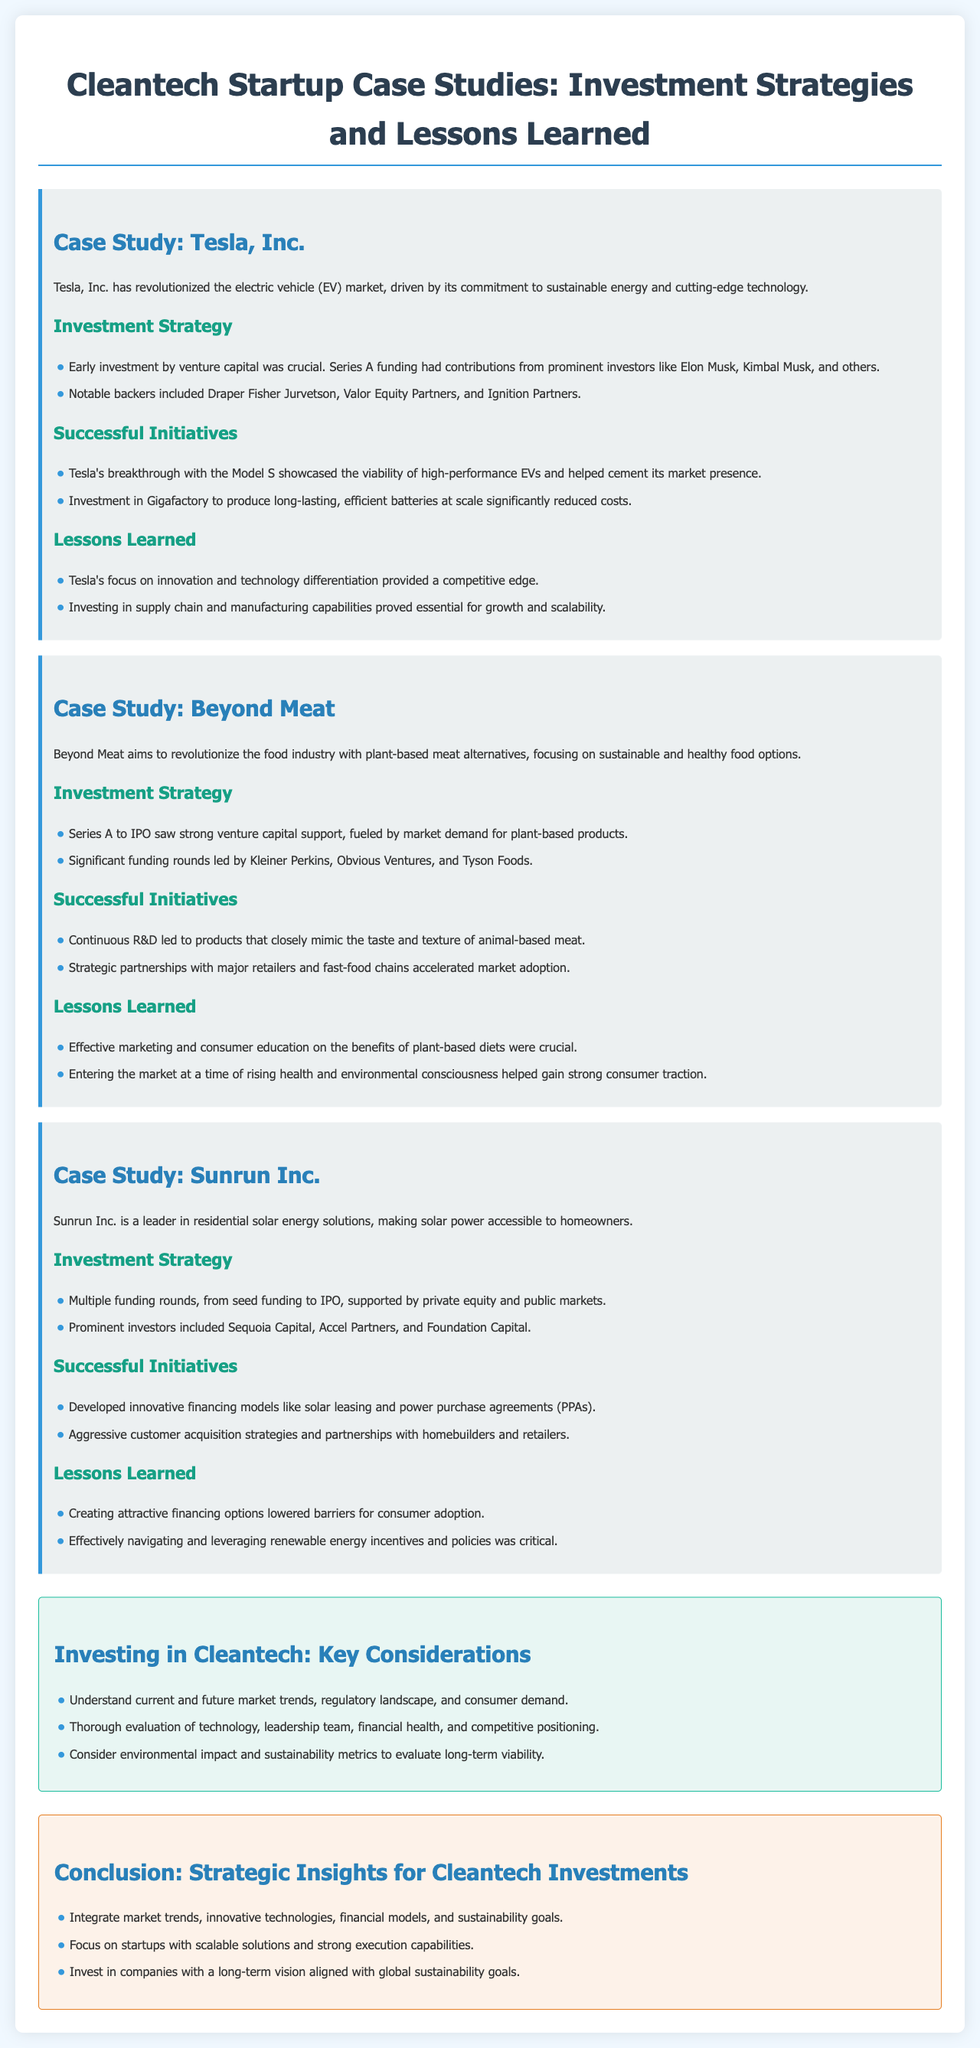What company is known for revolutionizing the electric vehicle market? The document states that Tesla, Inc. has revolutionized the electric vehicle market through its commitment to sustainable energy.
Answer: Tesla, Inc Who are the notable backers of Tesla's early funding? The document mentions that notable backers included Draper Fisher Jurvetson, Valor Equity Partners, and Ignition Partners.
Answer: Draper Fisher Jurvetson, Valor Equity Partners, Ignition Partners What innovative financing model did Sunrun develop? The document highlights that Sunrun developed innovative financing models like solar leasing and power purchase agreements (PPAs).
Answer: Solar leasing and power purchase agreements Which company focuses on plant-based meat alternatives? According to the document, Beyond Meat aims to revolutionize the food industry with plant-based meat alternatives.
Answer: Beyond Meat What is a key consideration for investing in cleantech? The document lists understanding current and future market trends as a key consideration for investing in cleantech.
Answer: Current and future market trends How many key considerations for investing in cleantech are mentioned? The document outlines three key considerations for investing in cleantech.
Answer: Three What initiative helped Tesla to significantly reduce costs? The document states that investment in Gigafactory to produce long-lasting, efficient batteries at scale significantly reduced costs for Tesla.
Answer: Gigafactory What was crucial for Beyond Meat's market adoption? The document mentions that strategic partnerships with major retailers and fast-food chains were crucial for Beyond Meat's market adoption.
Answer: Strategic partnerships What should be integrated for strategic cleantech investments? The document advises to integrate market trends, innovative technologies, financial models, and sustainability goals for strategic cleantech investments.
Answer: Market trends, innovative technologies, financial models, and sustainability goals 